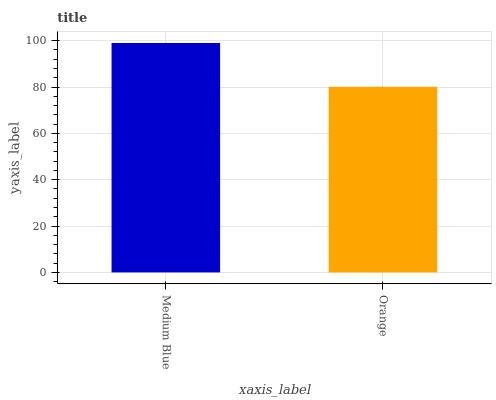Is Orange the minimum?
Answer yes or no. Yes. Is Medium Blue the maximum?
Answer yes or no. Yes. Is Orange the maximum?
Answer yes or no. No. Is Medium Blue greater than Orange?
Answer yes or no. Yes. Is Orange less than Medium Blue?
Answer yes or no. Yes. Is Orange greater than Medium Blue?
Answer yes or no. No. Is Medium Blue less than Orange?
Answer yes or no. No. Is Medium Blue the high median?
Answer yes or no. Yes. Is Orange the low median?
Answer yes or no. Yes. Is Orange the high median?
Answer yes or no. No. Is Medium Blue the low median?
Answer yes or no. No. 